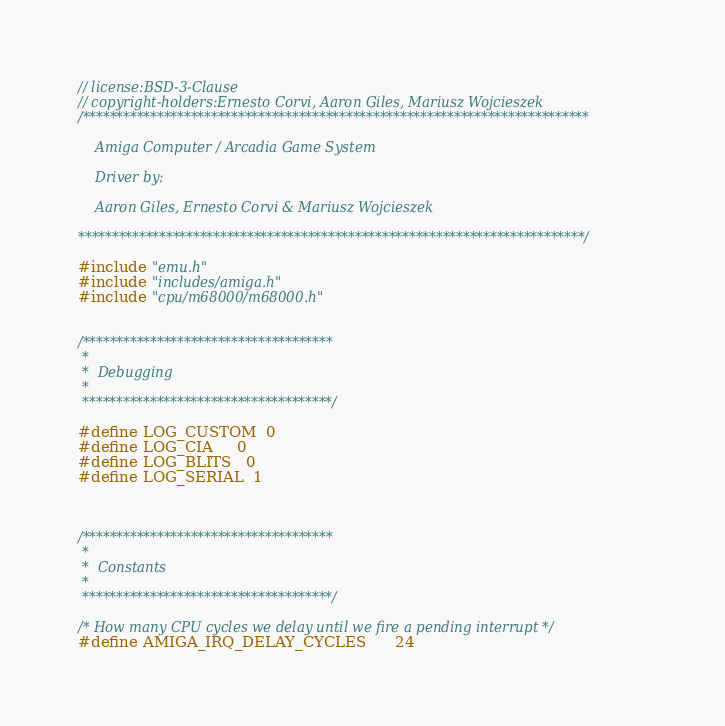<code> <loc_0><loc_0><loc_500><loc_500><_C++_>// license:BSD-3-Clause
// copyright-holders:Ernesto Corvi, Aaron Giles, Mariusz Wojcieszek
/***************************************************************************

    Amiga Computer / Arcadia Game System

    Driver by:

    Aaron Giles, Ernesto Corvi & Mariusz Wojcieszek

***************************************************************************/

#include "emu.h"
#include "includes/amiga.h"
#include "cpu/m68000/m68000.h"


/*************************************
 *
 *  Debugging
 *
 *************************************/

#define LOG_CUSTOM  0
#define LOG_CIA     0
#define LOG_BLITS   0
#define LOG_SERIAL  1



/*************************************
 *
 *  Constants
 *
 *************************************/

/* How many CPU cycles we delay until we fire a pending interrupt */
#define AMIGA_IRQ_DELAY_CYCLES      24
</code> 